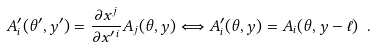Convert formula to latex. <formula><loc_0><loc_0><loc_500><loc_500>A _ { i } ^ { \prime } ( \theta ^ { \prime } , y ^ { \prime } ) = \frac { \partial x ^ { j } } { \partial x ^ { \prime \, i } } A _ { j } ( \theta , y ) \Longleftrightarrow A ^ { \prime } _ { i } ( \theta , y ) = A _ { i } ( \theta , y - \ell ) \ .</formula> 